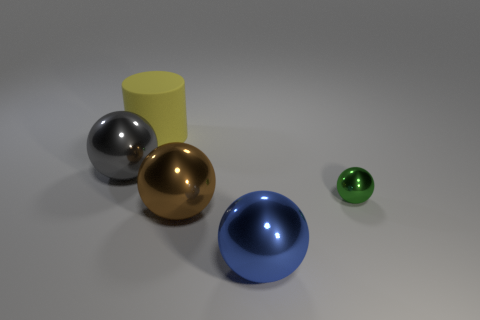Subtract all large brown shiny balls. How many balls are left? 3 Add 3 blue spheres. How many objects exist? 8 Subtract all brown balls. How many balls are left? 3 Subtract all spheres. How many objects are left? 1 Subtract all blue shiny balls. Subtract all big brown metallic balls. How many objects are left? 3 Add 4 brown metallic things. How many brown metallic things are left? 5 Add 3 green shiny balls. How many green shiny balls exist? 4 Subtract 0 red cylinders. How many objects are left? 5 Subtract 1 cylinders. How many cylinders are left? 0 Subtract all brown spheres. Subtract all purple cubes. How many spheres are left? 3 